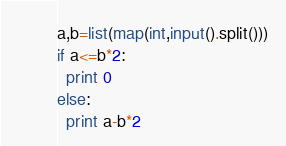Convert code to text. <code><loc_0><loc_0><loc_500><loc_500><_Python_>a,b=list(map(int,input().split()))
if a<=b*2:
  print 0
else:
  print a-b*2</code> 